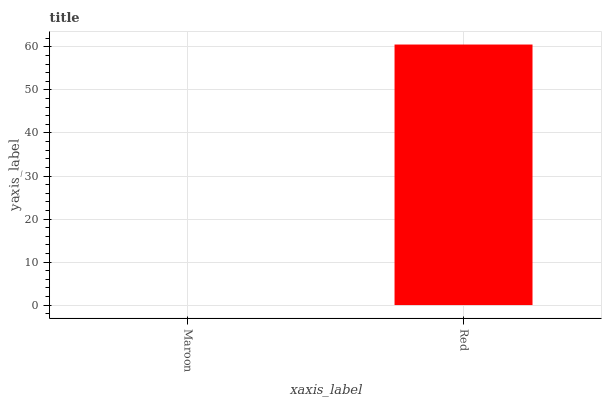Is Maroon the minimum?
Answer yes or no. Yes. Is Red the maximum?
Answer yes or no. Yes. Is Red the minimum?
Answer yes or no. No. Is Red greater than Maroon?
Answer yes or no. Yes. Is Maroon less than Red?
Answer yes or no. Yes. Is Maroon greater than Red?
Answer yes or no. No. Is Red less than Maroon?
Answer yes or no. No. Is Red the high median?
Answer yes or no. Yes. Is Maroon the low median?
Answer yes or no. Yes. Is Maroon the high median?
Answer yes or no. No. Is Red the low median?
Answer yes or no. No. 